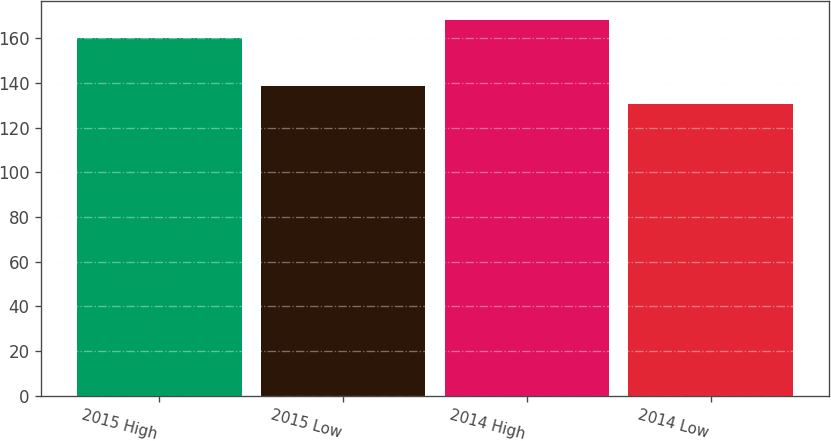Convert chart to OTSL. <chart><loc_0><loc_0><loc_500><loc_500><bar_chart><fcel>2015 High<fcel>2015 Low<fcel>2014 High<fcel>2014 Low<nl><fcel>160.09<fcel>138.57<fcel>168.16<fcel>130.6<nl></chart> 